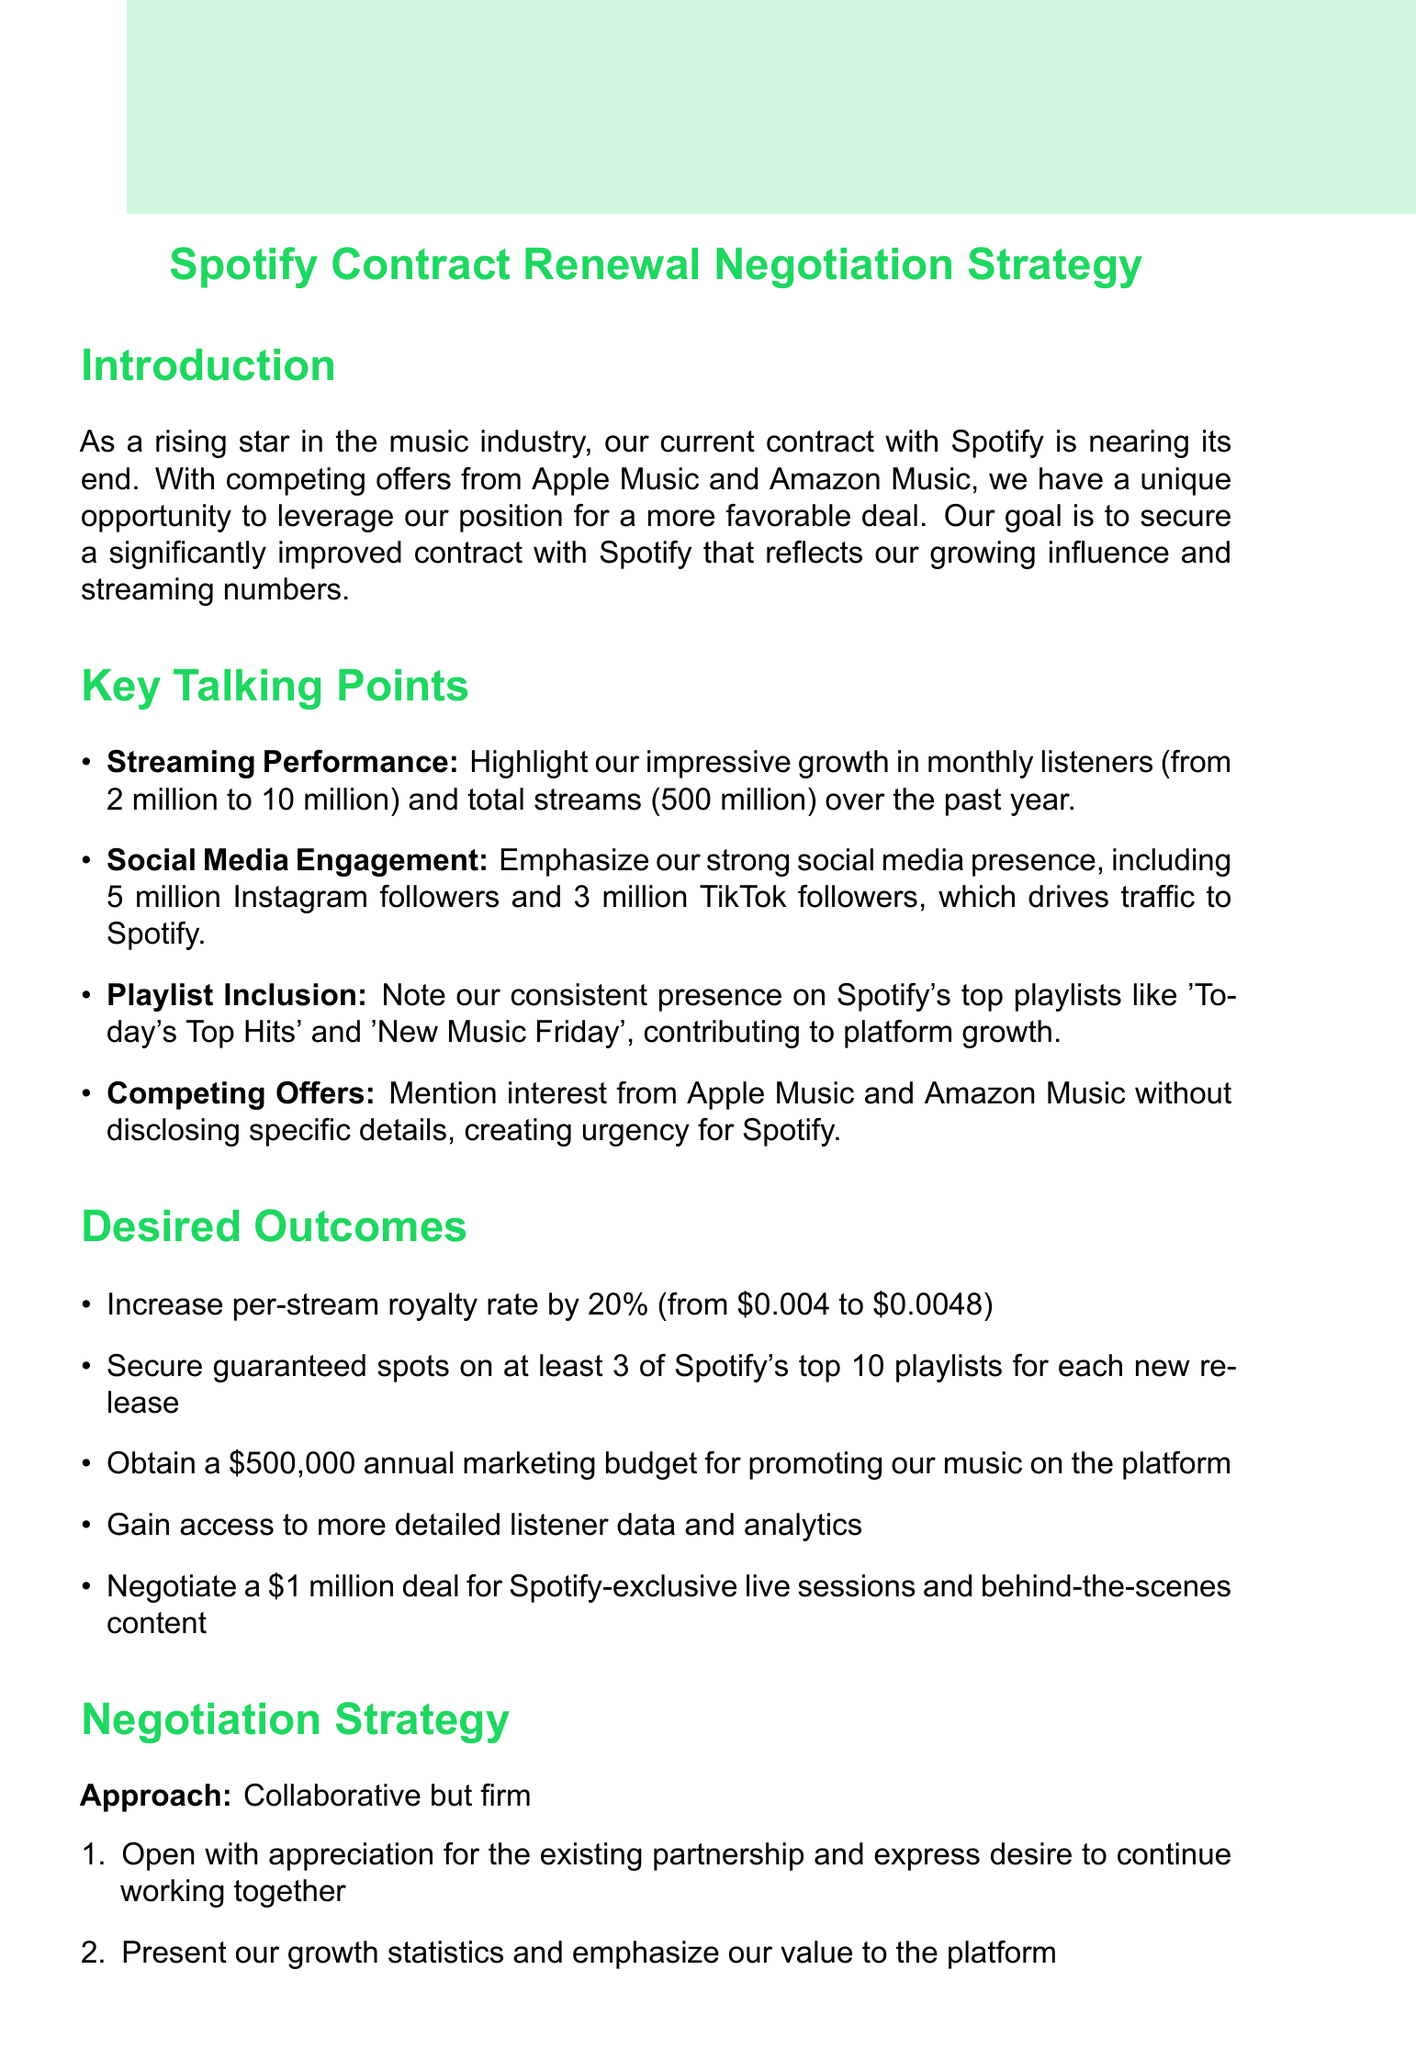What is the current number of monthly listeners? The current number of monthly listeners has grown from 2 million to 10 million over the past year.
Answer: 10 million What is the desired increase in per-stream royalty rate? The desired increase in per-stream royalty rate is specified in the desired outcomes section.
Answer: 20% Who is the Head of Artist Partnerships at Spotify? The document mentions the name of the individual to be contacted for negotiations as the Head of Artist Partnerships.
Answer: John Anderson What is the annual marketing budget being negotiated for? The specific amount for the annual marketing budget is outlined among the desired outcomes.
Answer: $500,000 What are the three potential concessions listed? The document explicitly mentions potential concessions, detailing three specific items to offer as part of negotiations.
Answer: Exclusive release window, fan engagement events, collaborative playlists What is the target number of guaranteed playlist placements? The target number of guaranteed playlist placements is stated in the desired outcomes section.
Answer: 3 What type of approach should be taken during negotiations? The document describes the negotiation approach to be taken in the negotiation strategy section.
Answer: Collaborative but firm How long is the timeline for finalizing the new contract? The document specifies the timeline for contract finalization in the next steps section.
Answer: 6 weeks 